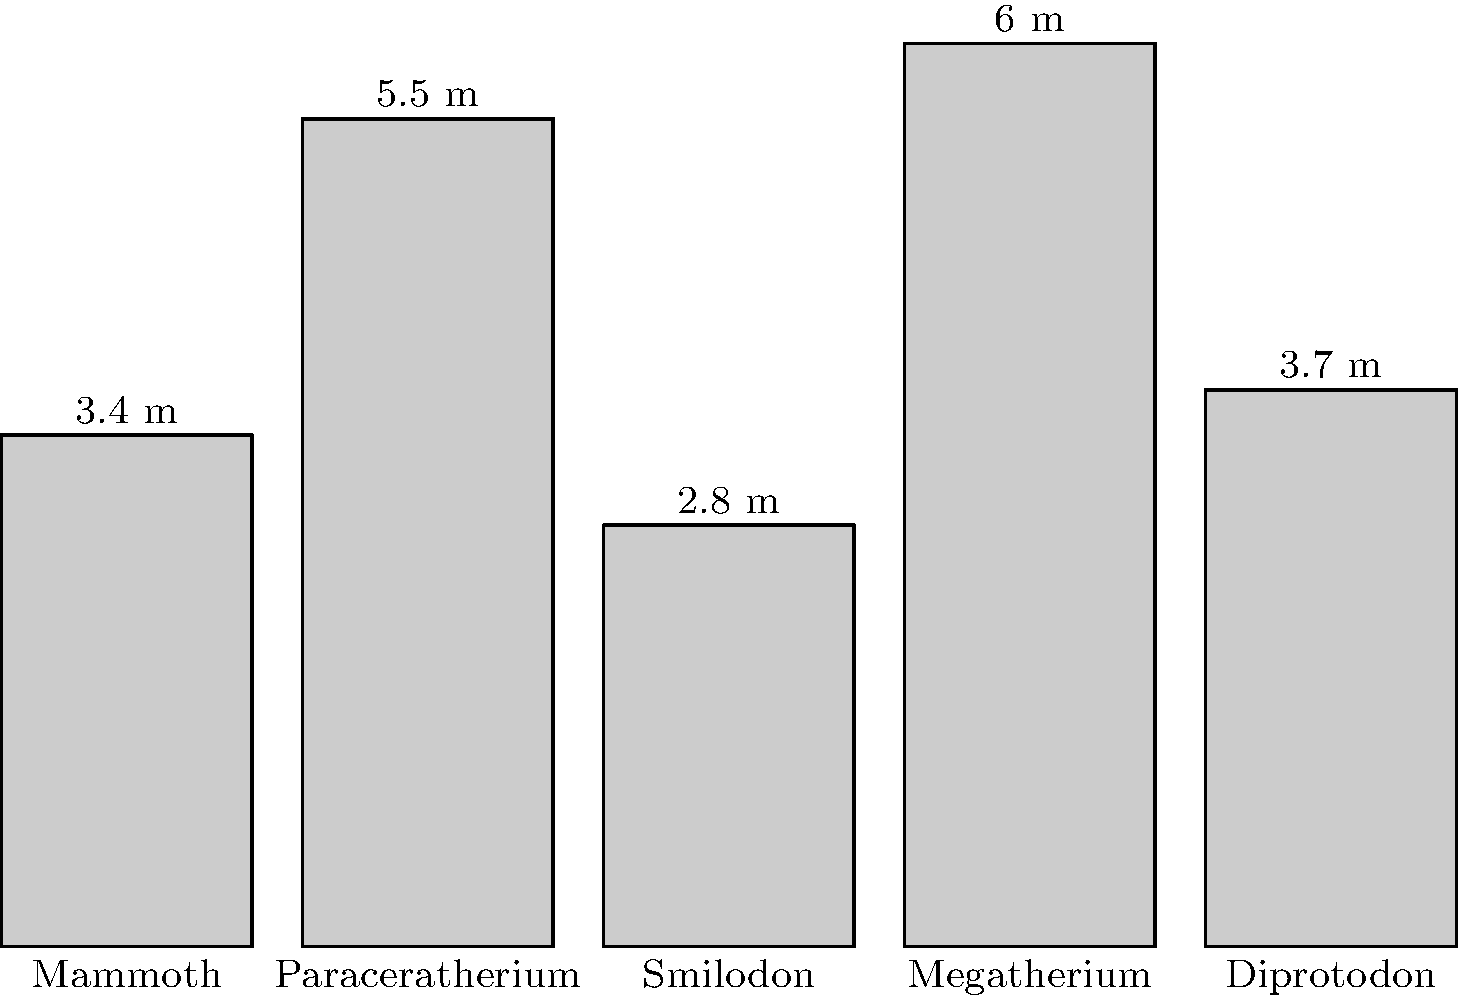Based on the silhouette diagram showing the heights of various extinct megafauna, which two species have the greatest height difference, and what is the magnitude of this difference? To find the two species with the greatest height difference and calculate that difference, we need to:

1. Identify the tallest and shortest species:
   - Tallest: Megatherium at 6.0 m
   - Shortest: Smilodon at 2.8 m

2. Calculate the difference between their heights:
   $6.0 \text{ m} - 2.8 \text{ m} = 3.2 \text{ m}$

3. Verify that no other pair of species has a larger difference:
   - Mammoth (3.4 m) and Paraceratherium (5.5 m): 2.1 m difference
   - Mammoth (3.4 m) and Diprotodon (3.7 m): 0.3 m difference
   - Paraceratherium (5.5 m) and Smilodon (2.8 m): 2.7 m difference
   - Megatherium (6.0 m) and Diprotodon (3.7 m): 2.3 m difference

The largest difference is indeed between Megatherium and Smilodon at 3.2 m.
Answer: Megatherium and Smilodon; 3.2 m 